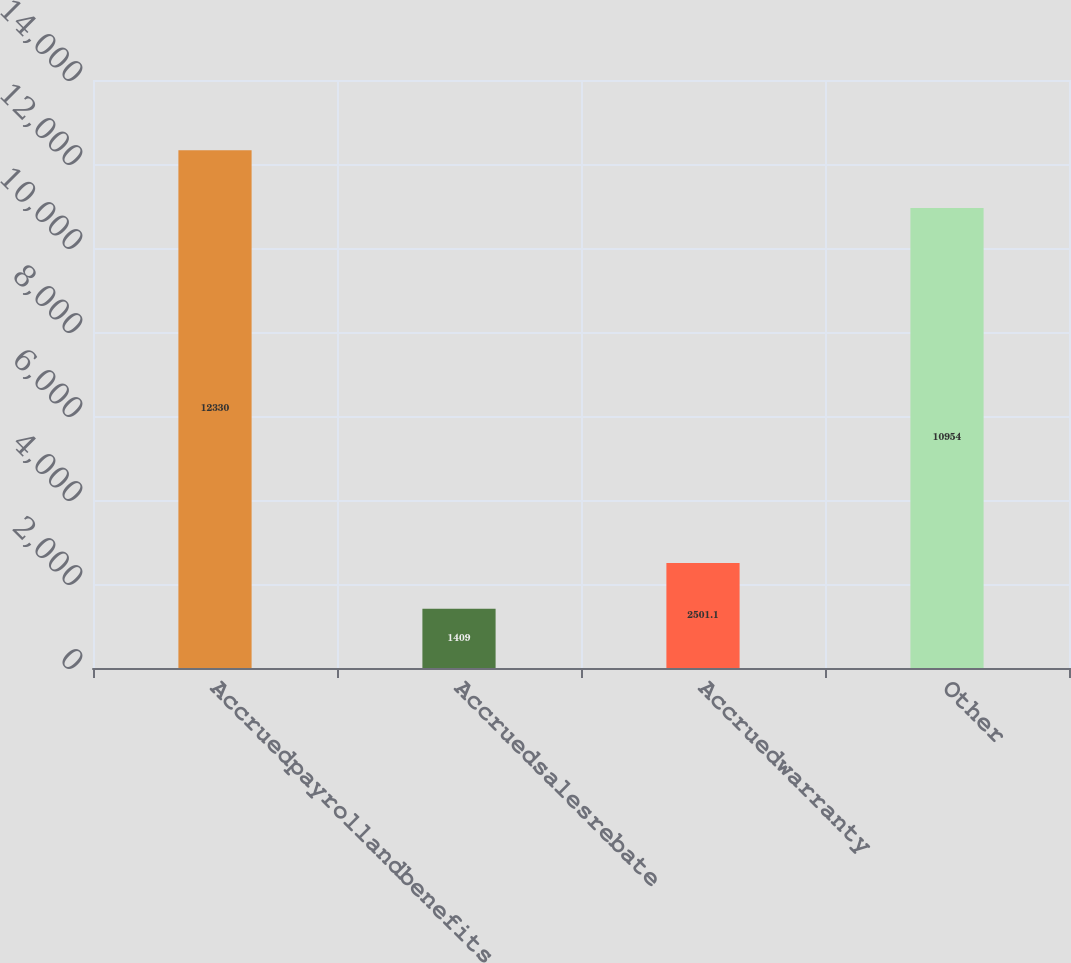<chart> <loc_0><loc_0><loc_500><loc_500><bar_chart><fcel>Accruedpayrollandbenefits<fcel>Accruedsalesrebate<fcel>Accruedwarranty<fcel>Other<nl><fcel>12330<fcel>1409<fcel>2501.1<fcel>10954<nl></chart> 